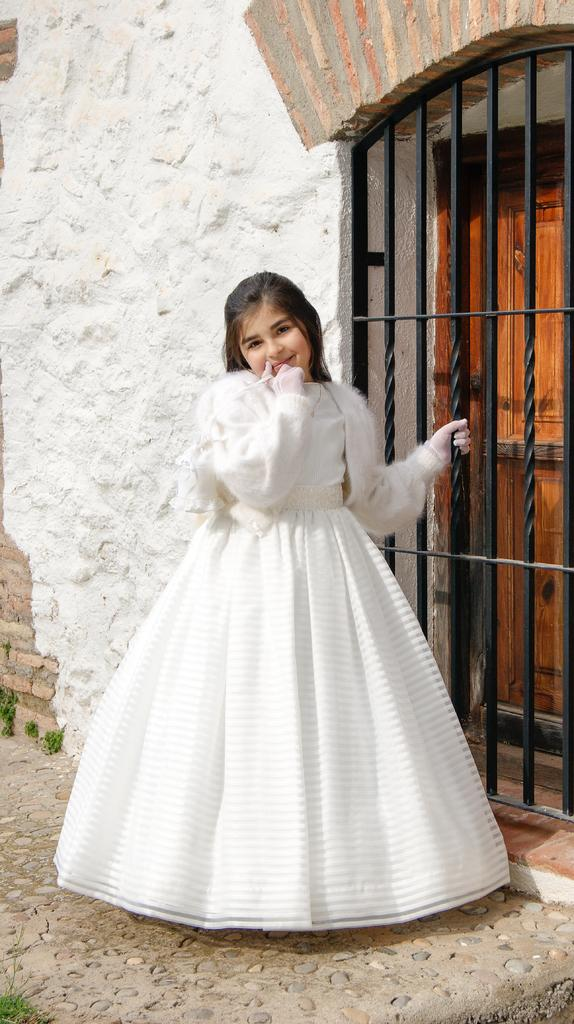Who is present in the image? There is a girl in the image. What is the girl's expression in the image? The girl is smiling in the image. What can be seen in the background of the image? There is a wall, a door, and a gate in the background of the image. What type of sweater is the girl wearing in the image? There is no sweater visible in the image; the girl is not wearing any clothing mentioned in the facts. 